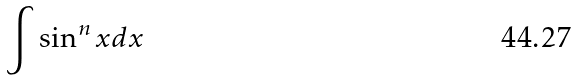<formula> <loc_0><loc_0><loc_500><loc_500>\int \sin ^ { n } x d x</formula> 